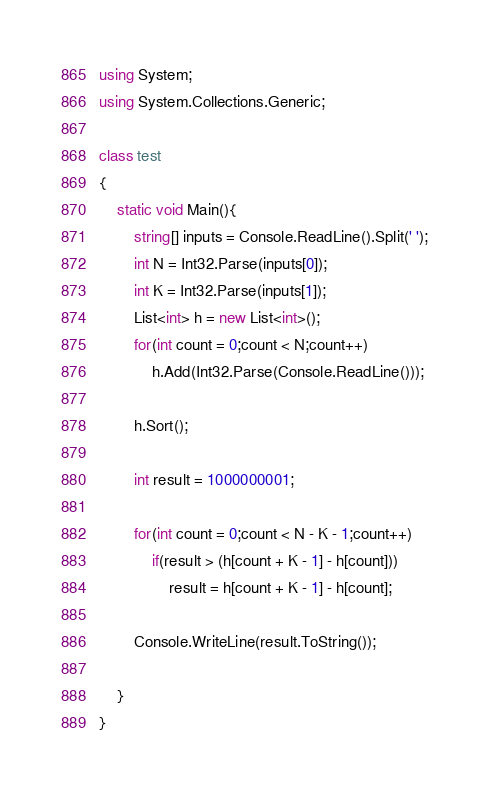Convert code to text. <code><loc_0><loc_0><loc_500><loc_500><_C#_>using System;
using System.Collections.Generic;

class test
{
    static void Main(){
        string[] inputs = Console.ReadLine().Split(' ');
        int N = Int32.Parse(inputs[0]);
        int K = Int32.Parse(inputs[1]);
        List<int> h = new List<int>();
        for(int count = 0;count < N;count++)
            h.Add(Int32.Parse(Console.ReadLine()));

        h.Sort();

        int result = 1000000001;

        for(int count = 0;count < N - K - 1;count++)
            if(result > (h[count + K - 1] - h[count]))
                result = h[count + K - 1] - h[count];

        Console.WriteLine(result.ToString());

    }
}</code> 